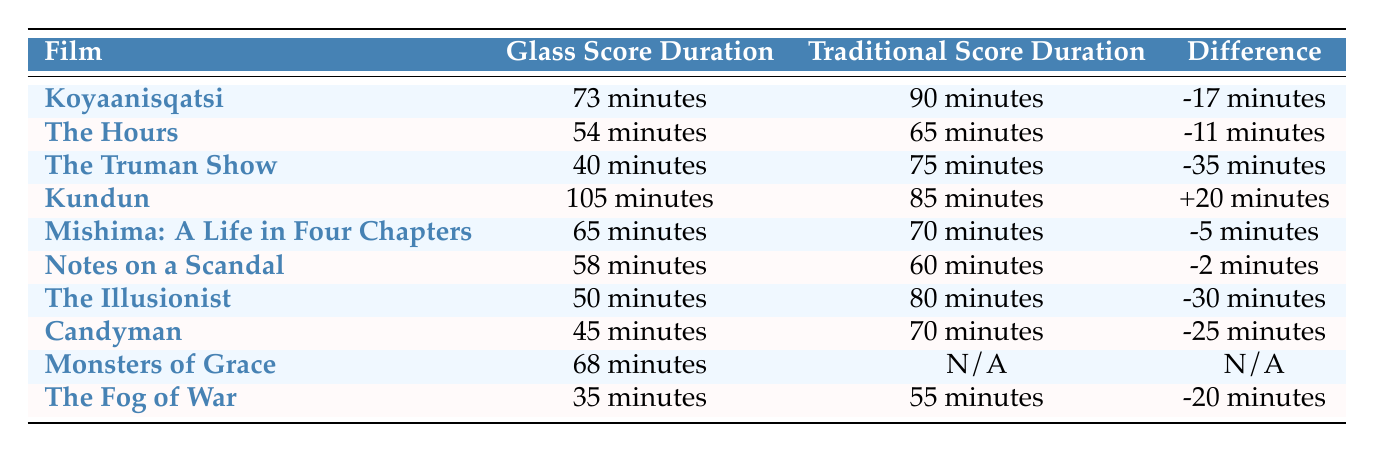What is the Glass score duration for "Koyaanisqatsi"? The Glass score duration for "Koyaanisqatsi" is directly listed in the table under the "Glass Score Duration" column, which shows "73 minutes".
Answer: 73 minutes What is the difference in duration between Glass's score and traditional score for "Kundun"? The difference is stated in the table under the "Difference" column for "Kundun", which indicates "+20 minutes".
Answer: +20 minutes Was the Glass score duration longer than the traditional score duration for "Kundun"? The table shows that the Glass score duration for "Kundun" is 105 minutes, while the traditional score duration is 85 minutes. Since 105 is greater than 85, the answer is yes.
Answer: Yes How many films had a negative difference in score duration? To find this, I look at the "Difference" column and count the entries that have a "-" sign. There are six films ("Koyaanisqatsi", "The Hours", "The Truman Show", "Mishima", "Notes on a Scandal", "The Illusionist", "Candyman", "The Fog of War") with negative differences.
Answer: 6 What is the average duration difference in minutes for the films listed? First, I sum the differences from the "Difference" column: -17 + -11 + -35 + 20 + -5 + -2 + -30 + -25 + -20 = -115. Since there are 9 films, the average is -115/9 = approximately -12.78. Therefore I will round the answer to -13.
Answer: -13 Which film had the shortest Glass score duration and what was its duration? Reviewing the "Glass Score Duration" column, "The Fog of War" has the shortest duration of 35 minutes.
Answer: The Fog of War, 35 minutes What is the traditional score duration for "Monsters of Grace"? The table indicates "N/A" under the "Traditional Score Duration" for "Monsters of Grace". Therefore, it has no available duration.
Answer: N/A Is the average Glass score duration shorter than 60 minutes? To assess this, I calculate the average of the Glass score durations: (73 + 54 + 40 + 105 + 65 + 58 + 50 + 45 + 68 + 35)/10 = 54.8 minutes, which is less than 60. Hence the statement is true.
Answer: Yes How many films have a traditional score duration of 70 minutes or more? I check the "Traditional Score Duration" column: traditional scores of "The Truman Show", "The Illusionist", and "Candyman" (75, 80, 70 minutes) all qualify, totaling four films "Kundun" (85), "Monsters of Grace" (N/A does not count). Total films with duration 70 minutes or more is 5.
Answer: 5 